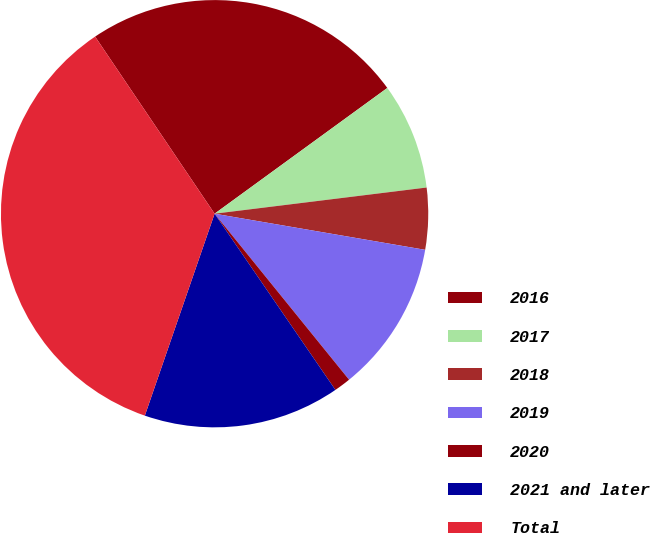<chart> <loc_0><loc_0><loc_500><loc_500><pie_chart><fcel>2016<fcel>2017<fcel>2018<fcel>2019<fcel>2020<fcel>2021 and later<fcel>Total<nl><fcel>24.43%<fcel>8.06%<fcel>4.66%<fcel>11.46%<fcel>1.27%<fcel>14.86%<fcel>35.26%<nl></chart> 